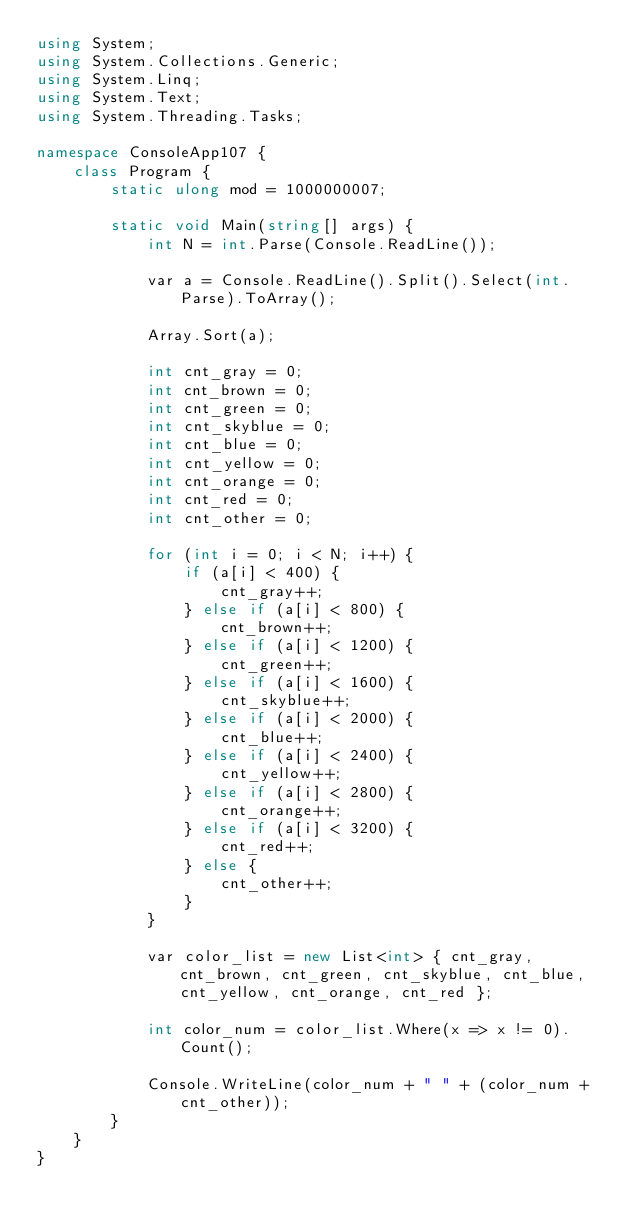Convert code to text. <code><loc_0><loc_0><loc_500><loc_500><_C#_>using System;
using System.Collections.Generic;
using System.Linq;
using System.Text;
using System.Threading.Tasks;

namespace ConsoleApp107 {
    class Program {
        static ulong mod = 1000000007;

        static void Main(string[] args) {
            int N = int.Parse(Console.ReadLine());

            var a = Console.ReadLine().Split().Select(int.Parse).ToArray();

            Array.Sort(a);

            int cnt_gray = 0;
            int cnt_brown = 0;
            int cnt_green = 0;
            int cnt_skyblue = 0;
            int cnt_blue = 0;
            int cnt_yellow = 0;
            int cnt_orange = 0;
            int cnt_red = 0;
            int cnt_other = 0;

            for (int i = 0; i < N; i++) {
                if (a[i] < 400) {
                    cnt_gray++;
                } else if (a[i] < 800) {
                    cnt_brown++;
                } else if (a[i] < 1200) {
                    cnt_green++;
                } else if (a[i] < 1600) {
                    cnt_skyblue++;
                } else if (a[i] < 2000) {
                    cnt_blue++;
                } else if (a[i] < 2400) {
                    cnt_yellow++;
                } else if (a[i] < 2800) {
                    cnt_orange++;
                } else if (a[i] < 3200) {
                    cnt_red++;
                } else {
                    cnt_other++;
                }
            }

            var color_list = new List<int> { cnt_gray, cnt_brown, cnt_green, cnt_skyblue, cnt_blue, cnt_yellow, cnt_orange, cnt_red };

            int color_num = color_list.Where(x => x != 0).Count();

            Console.WriteLine(color_num + " " + (color_num + cnt_other));
        }
    }
}
</code> 